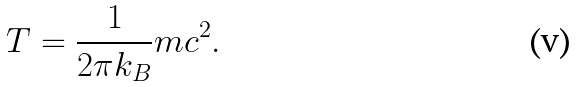<formula> <loc_0><loc_0><loc_500><loc_500>T = \frac { 1 } { 2 \pi k _ { B } } m c ^ { 2 } .</formula> 